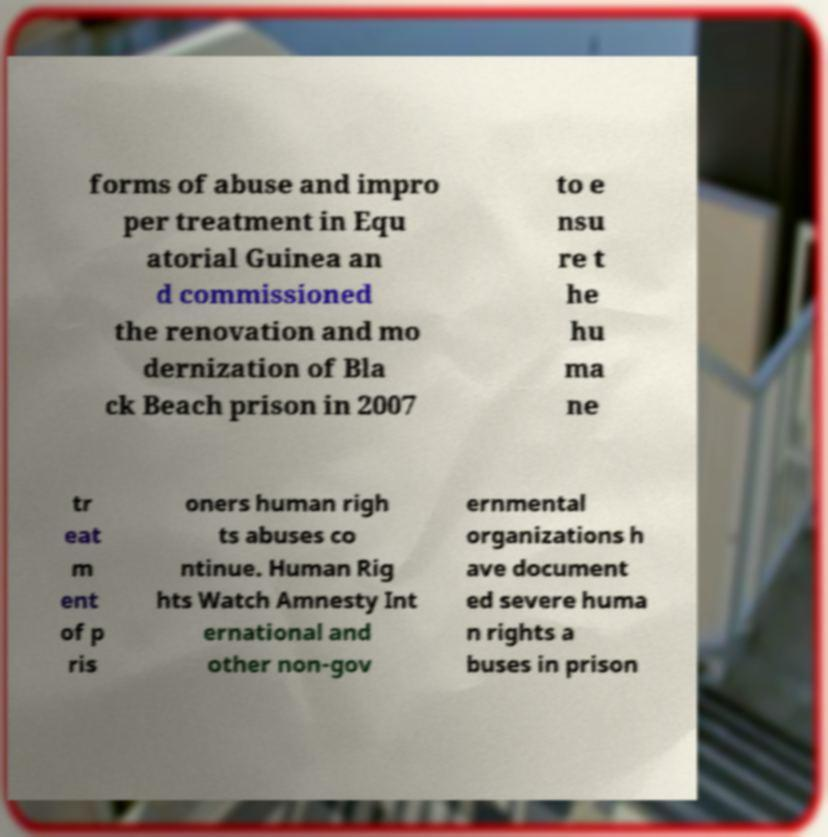Could you assist in decoding the text presented in this image and type it out clearly? forms of abuse and impro per treatment in Equ atorial Guinea an d commissioned the renovation and mo dernization of Bla ck Beach prison in 2007 to e nsu re t he hu ma ne tr eat m ent of p ris oners human righ ts abuses co ntinue. Human Rig hts Watch Amnesty Int ernational and other non-gov ernmental organizations h ave document ed severe huma n rights a buses in prison 